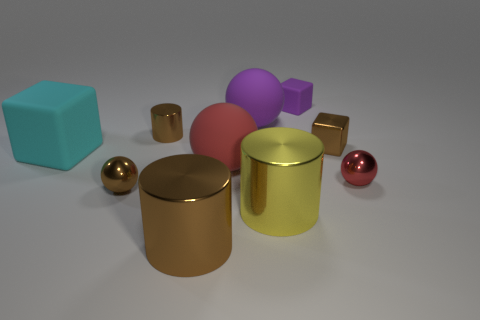Subtract all cubes. How many objects are left? 7 Add 5 large red rubber objects. How many large red rubber objects exist? 6 Subtract 1 yellow cylinders. How many objects are left? 9 Subtract all rubber cubes. Subtract all brown shiny cylinders. How many objects are left? 6 Add 5 big yellow metallic cylinders. How many big yellow metallic cylinders are left? 6 